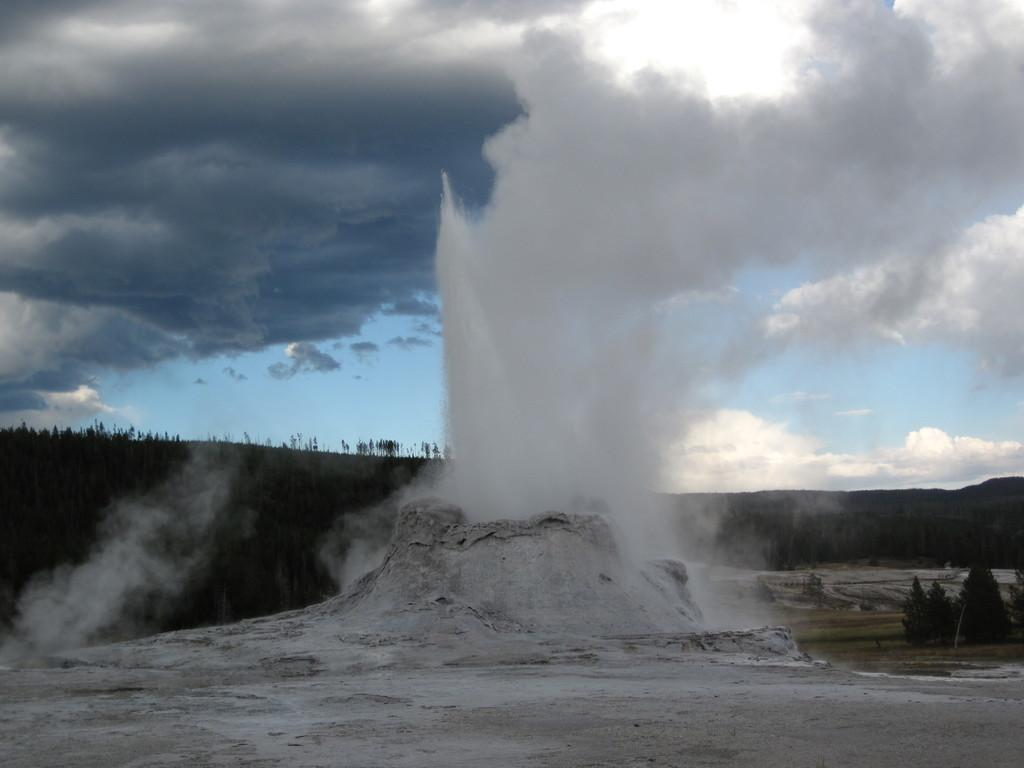What can be seen in the image that is not a solid color? There is white smoke in the image. What type of natural vegetation is present in the image? There are trees in the image. What is on the ground in the image? There are objects on the ground in the image. What is visible in the distance in the image? The sky is visible in the background of the image. What type of fruit is hanging from the trees in the image? There is no fruit visible in the image; only trees and white smoke are present. Are there any cushions visible in the image? There are no cushions present in the image. 